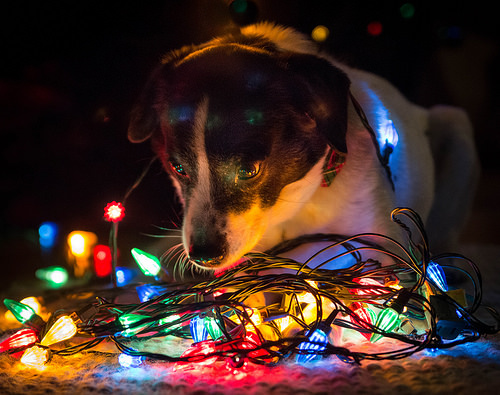<image>
Can you confirm if the lights is under the dog? Yes. The lights is positioned underneath the dog, with the dog above it in the vertical space. Is the light on the dog? Yes. Looking at the image, I can see the light is positioned on top of the dog, with the dog providing support. Is the dog on the green bulb? No. The dog is not positioned on the green bulb. They may be near each other, but the dog is not supported by or resting on top of the green bulb. 